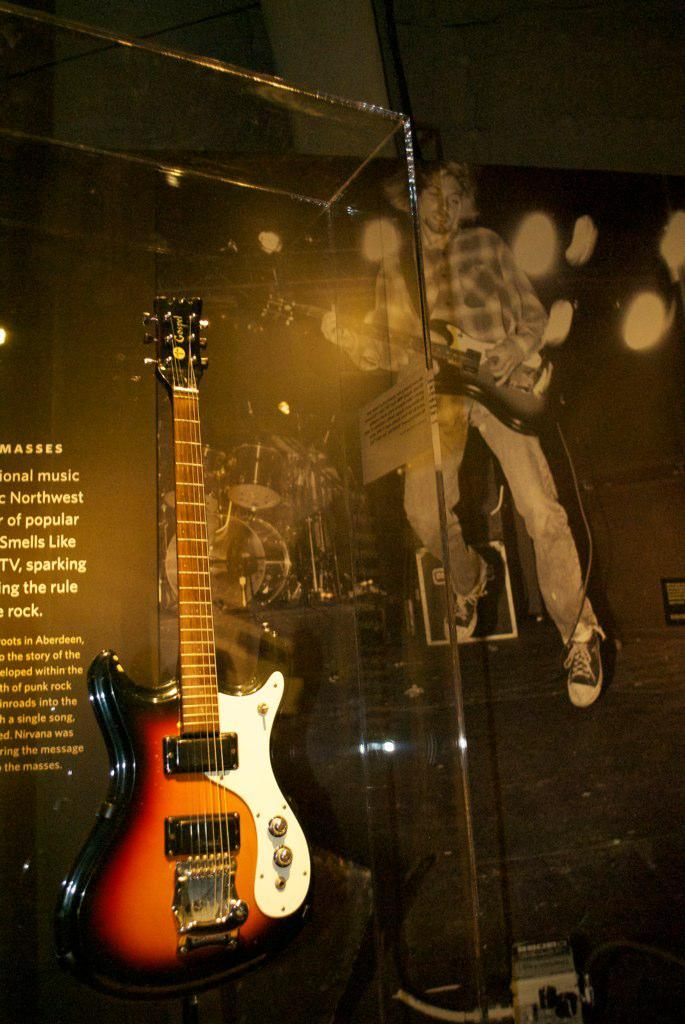Who is present in the image? There is a man in the image. What is the man holding in the image? The man is holding a guitar. Are there any other guitars visible in the image? Yes, there is another guitar on the left side of the image. What type of chess piece is the man holding in the image? The man is not holding a chess piece in the image; he is holding a guitar. Is there a bathtub visible in the image? There is no bathtub present in the image. 